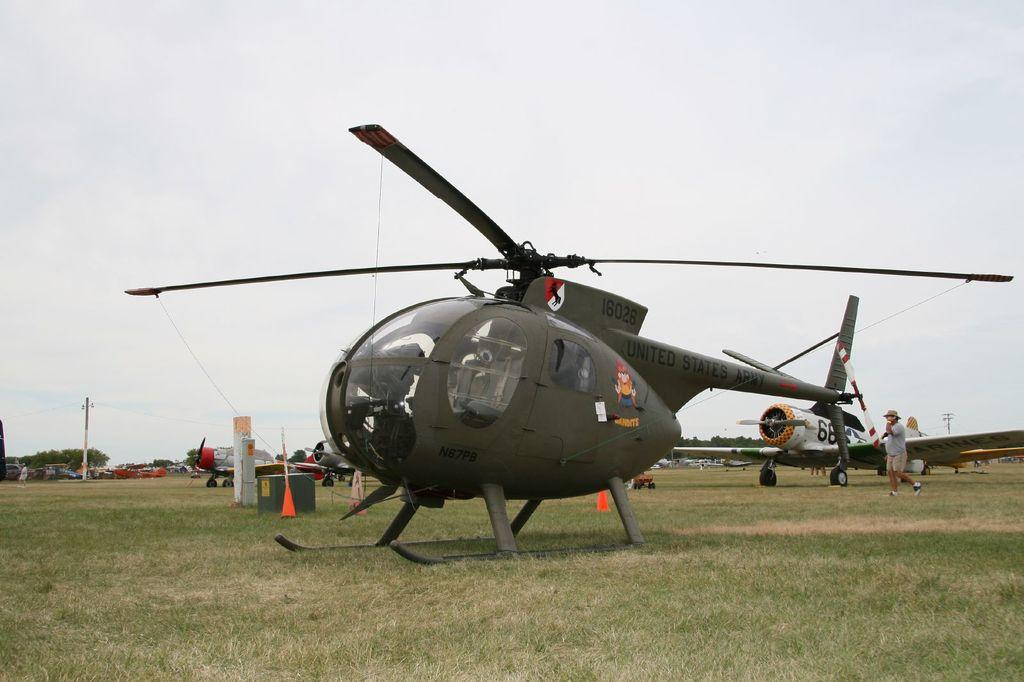What type of vehicles are present in the image? There are two helicopters in the image. What architectural features can be seen in the image? There are pillars and poles in the image. What type of vegetation is visible in the image? There are trees in the image. What living organisms are present in the image? There are people standing in the image. What is visible in the background of the image? The sky is visible in the background of the image. Can you tell me how many clovers are growing near the helicopters in the image? There are no clovers present in the image. What type of laborer is working on the helicopters in the image? There are no laborers working on the helicopters in the image; the people present are standing, not working on the helicopters. 